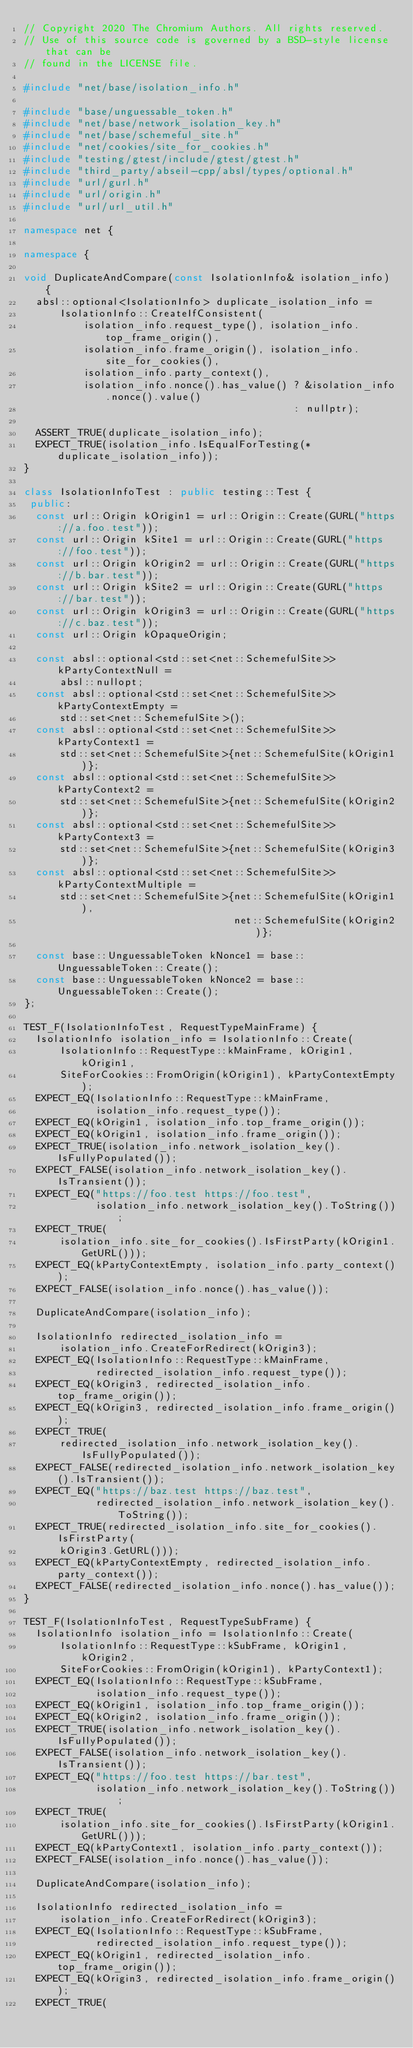<code> <loc_0><loc_0><loc_500><loc_500><_C++_>// Copyright 2020 The Chromium Authors. All rights reserved.
// Use of this source code is governed by a BSD-style license that can be
// found in the LICENSE file.

#include "net/base/isolation_info.h"

#include "base/unguessable_token.h"
#include "net/base/network_isolation_key.h"
#include "net/base/schemeful_site.h"
#include "net/cookies/site_for_cookies.h"
#include "testing/gtest/include/gtest/gtest.h"
#include "third_party/abseil-cpp/absl/types/optional.h"
#include "url/gurl.h"
#include "url/origin.h"
#include "url/url_util.h"

namespace net {

namespace {

void DuplicateAndCompare(const IsolationInfo& isolation_info) {
  absl::optional<IsolationInfo> duplicate_isolation_info =
      IsolationInfo::CreateIfConsistent(
          isolation_info.request_type(), isolation_info.top_frame_origin(),
          isolation_info.frame_origin(), isolation_info.site_for_cookies(),
          isolation_info.party_context(),
          isolation_info.nonce().has_value() ? &isolation_info.nonce().value()
                                             : nullptr);

  ASSERT_TRUE(duplicate_isolation_info);
  EXPECT_TRUE(isolation_info.IsEqualForTesting(*duplicate_isolation_info));
}

class IsolationInfoTest : public testing::Test {
 public:
  const url::Origin kOrigin1 = url::Origin::Create(GURL("https://a.foo.test"));
  const url::Origin kSite1 = url::Origin::Create(GURL("https://foo.test"));
  const url::Origin kOrigin2 = url::Origin::Create(GURL("https://b.bar.test"));
  const url::Origin kSite2 = url::Origin::Create(GURL("https://bar.test"));
  const url::Origin kOrigin3 = url::Origin::Create(GURL("https://c.baz.test"));
  const url::Origin kOpaqueOrigin;

  const absl::optional<std::set<net::SchemefulSite>> kPartyContextNull =
      absl::nullopt;
  const absl::optional<std::set<net::SchemefulSite>> kPartyContextEmpty =
      std::set<net::SchemefulSite>();
  const absl::optional<std::set<net::SchemefulSite>> kPartyContext1 =
      std::set<net::SchemefulSite>{net::SchemefulSite(kOrigin1)};
  const absl::optional<std::set<net::SchemefulSite>> kPartyContext2 =
      std::set<net::SchemefulSite>{net::SchemefulSite(kOrigin2)};
  const absl::optional<std::set<net::SchemefulSite>> kPartyContext3 =
      std::set<net::SchemefulSite>{net::SchemefulSite(kOrigin3)};
  const absl::optional<std::set<net::SchemefulSite>> kPartyContextMultiple =
      std::set<net::SchemefulSite>{net::SchemefulSite(kOrigin1),
                                   net::SchemefulSite(kOrigin2)};

  const base::UnguessableToken kNonce1 = base::UnguessableToken::Create();
  const base::UnguessableToken kNonce2 = base::UnguessableToken::Create();
};

TEST_F(IsolationInfoTest, RequestTypeMainFrame) {
  IsolationInfo isolation_info = IsolationInfo::Create(
      IsolationInfo::RequestType::kMainFrame, kOrigin1, kOrigin1,
      SiteForCookies::FromOrigin(kOrigin1), kPartyContextEmpty);
  EXPECT_EQ(IsolationInfo::RequestType::kMainFrame,
            isolation_info.request_type());
  EXPECT_EQ(kOrigin1, isolation_info.top_frame_origin());
  EXPECT_EQ(kOrigin1, isolation_info.frame_origin());
  EXPECT_TRUE(isolation_info.network_isolation_key().IsFullyPopulated());
  EXPECT_FALSE(isolation_info.network_isolation_key().IsTransient());
  EXPECT_EQ("https://foo.test https://foo.test",
            isolation_info.network_isolation_key().ToString());
  EXPECT_TRUE(
      isolation_info.site_for_cookies().IsFirstParty(kOrigin1.GetURL()));
  EXPECT_EQ(kPartyContextEmpty, isolation_info.party_context());
  EXPECT_FALSE(isolation_info.nonce().has_value());

  DuplicateAndCompare(isolation_info);

  IsolationInfo redirected_isolation_info =
      isolation_info.CreateForRedirect(kOrigin3);
  EXPECT_EQ(IsolationInfo::RequestType::kMainFrame,
            redirected_isolation_info.request_type());
  EXPECT_EQ(kOrigin3, redirected_isolation_info.top_frame_origin());
  EXPECT_EQ(kOrigin3, redirected_isolation_info.frame_origin());
  EXPECT_TRUE(
      redirected_isolation_info.network_isolation_key().IsFullyPopulated());
  EXPECT_FALSE(redirected_isolation_info.network_isolation_key().IsTransient());
  EXPECT_EQ("https://baz.test https://baz.test",
            redirected_isolation_info.network_isolation_key().ToString());
  EXPECT_TRUE(redirected_isolation_info.site_for_cookies().IsFirstParty(
      kOrigin3.GetURL()));
  EXPECT_EQ(kPartyContextEmpty, redirected_isolation_info.party_context());
  EXPECT_FALSE(redirected_isolation_info.nonce().has_value());
}

TEST_F(IsolationInfoTest, RequestTypeSubFrame) {
  IsolationInfo isolation_info = IsolationInfo::Create(
      IsolationInfo::RequestType::kSubFrame, kOrigin1, kOrigin2,
      SiteForCookies::FromOrigin(kOrigin1), kPartyContext1);
  EXPECT_EQ(IsolationInfo::RequestType::kSubFrame,
            isolation_info.request_type());
  EXPECT_EQ(kOrigin1, isolation_info.top_frame_origin());
  EXPECT_EQ(kOrigin2, isolation_info.frame_origin());
  EXPECT_TRUE(isolation_info.network_isolation_key().IsFullyPopulated());
  EXPECT_FALSE(isolation_info.network_isolation_key().IsTransient());
  EXPECT_EQ("https://foo.test https://bar.test",
            isolation_info.network_isolation_key().ToString());
  EXPECT_TRUE(
      isolation_info.site_for_cookies().IsFirstParty(kOrigin1.GetURL()));
  EXPECT_EQ(kPartyContext1, isolation_info.party_context());
  EXPECT_FALSE(isolation_info.nonce().has_value());

  DuplicateAndCompare(isolation_info);

  IsolationInfo redirected_isolation_info =
      isolation_info.CreateForRedirect(kOrigin3);
  EXPECT_EQ(IsolationInfo::RequestType::kSubFrame,
            redirected_isolation_info.request_type());
  EXPECT_EQ(kOrigin1, redirected_isolation_info.top_frame_origin());
  EXPECT_EQ(kOrigin3, redirected_isolation_info.frame_origin());
  EXPECT_TRUE(</code> 